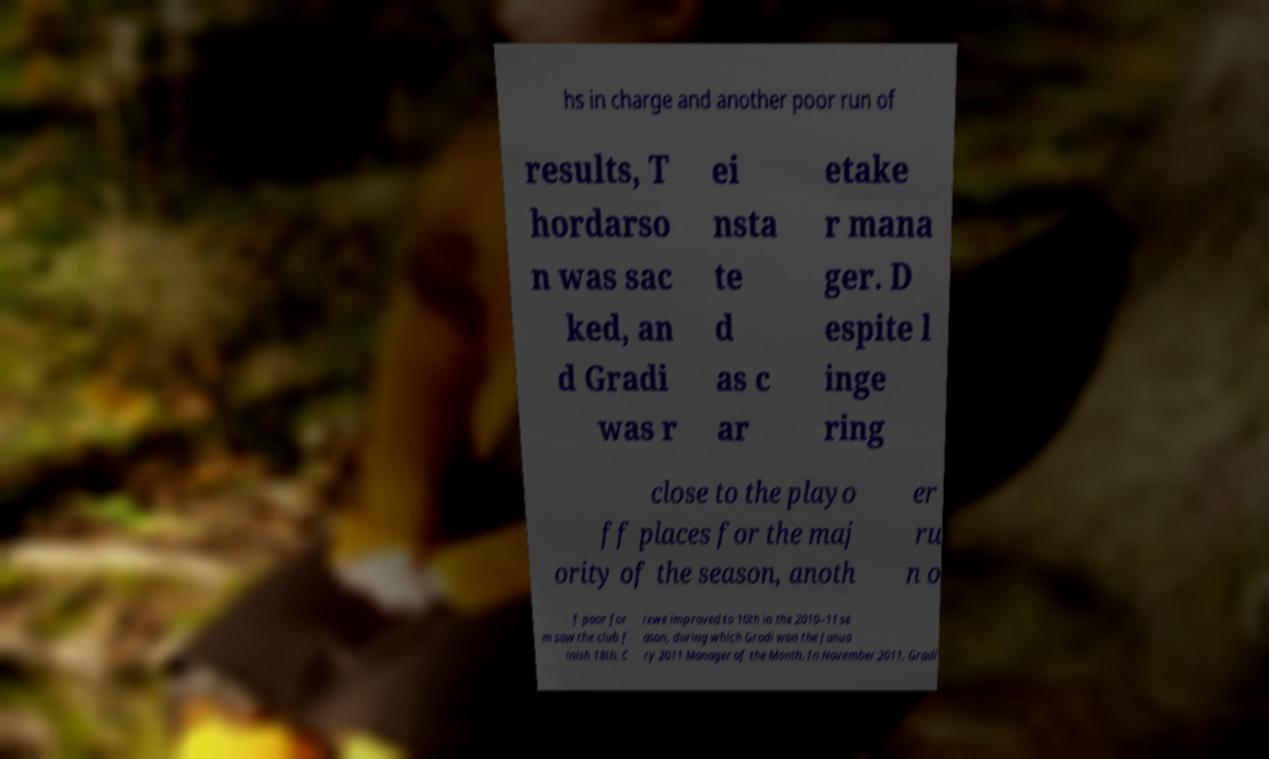For documentation purposes, I need the text within this image transcribed. Could you provide that? hs in charge and another poor run of results, T hordarso n was sac ked, an d Gradi was r ei nsta te d as c ar etake r mana ger. D espite l inge ring close to the playo ff places for the maj ority of the season, anoth er ru n o f poor for m saw the club f inish 18th. C rewe improved to 10th in the 2010–11 se ason, during which Gradi won the Janua ry 2011 Manager of the Month. In November 2011, Gradi 